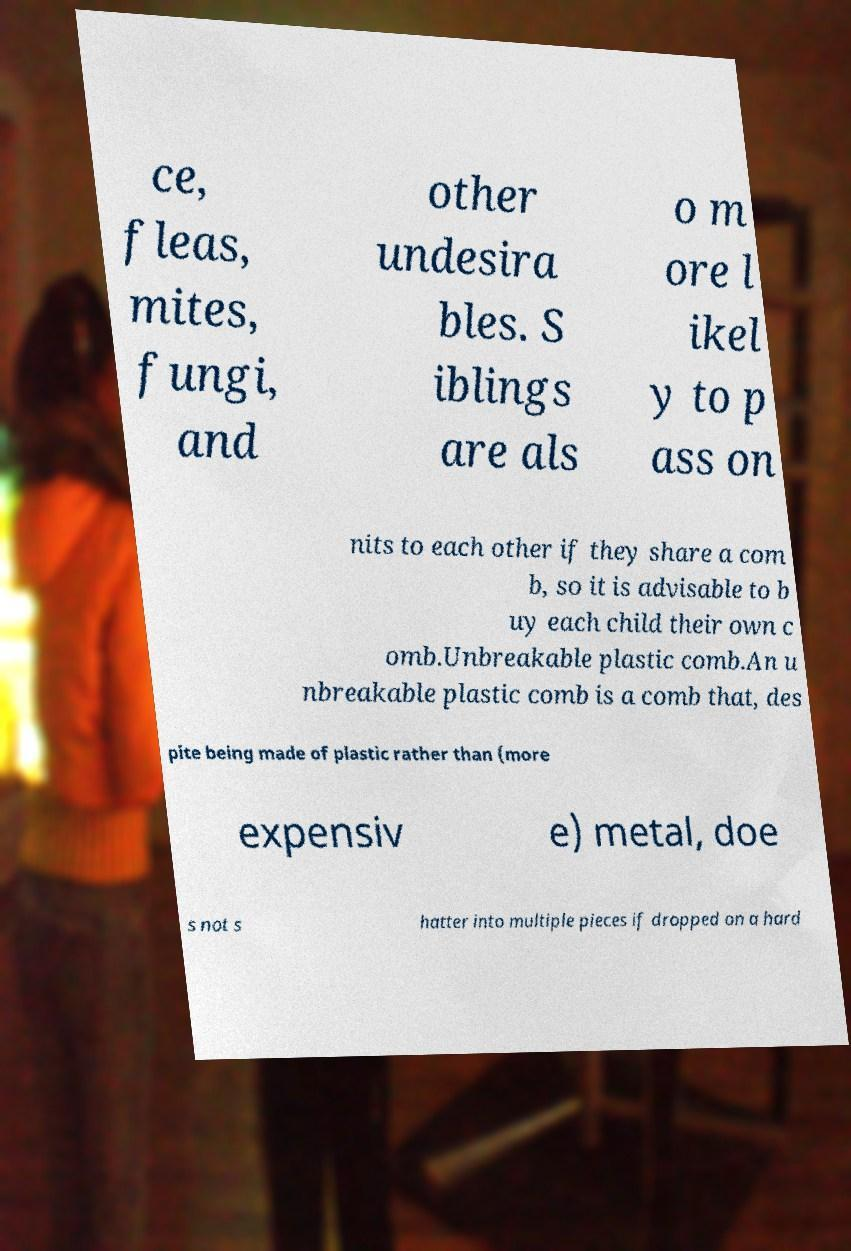Could you extract and type out the text from this image? ce, fleas, mites, fungi, and other undesira bles. S iblings are als o m ore l ikel y to p ass on nits to each other if they share a com b, so it is advisable to b uy each child their own c omb.Unbreakable plastic comb.An u nbreakable plastic comb is a comb that, des pite being made of plastic rather than (more expensiv e) metal, doe s not s hatter into multiple pieces if dropped on a hard 